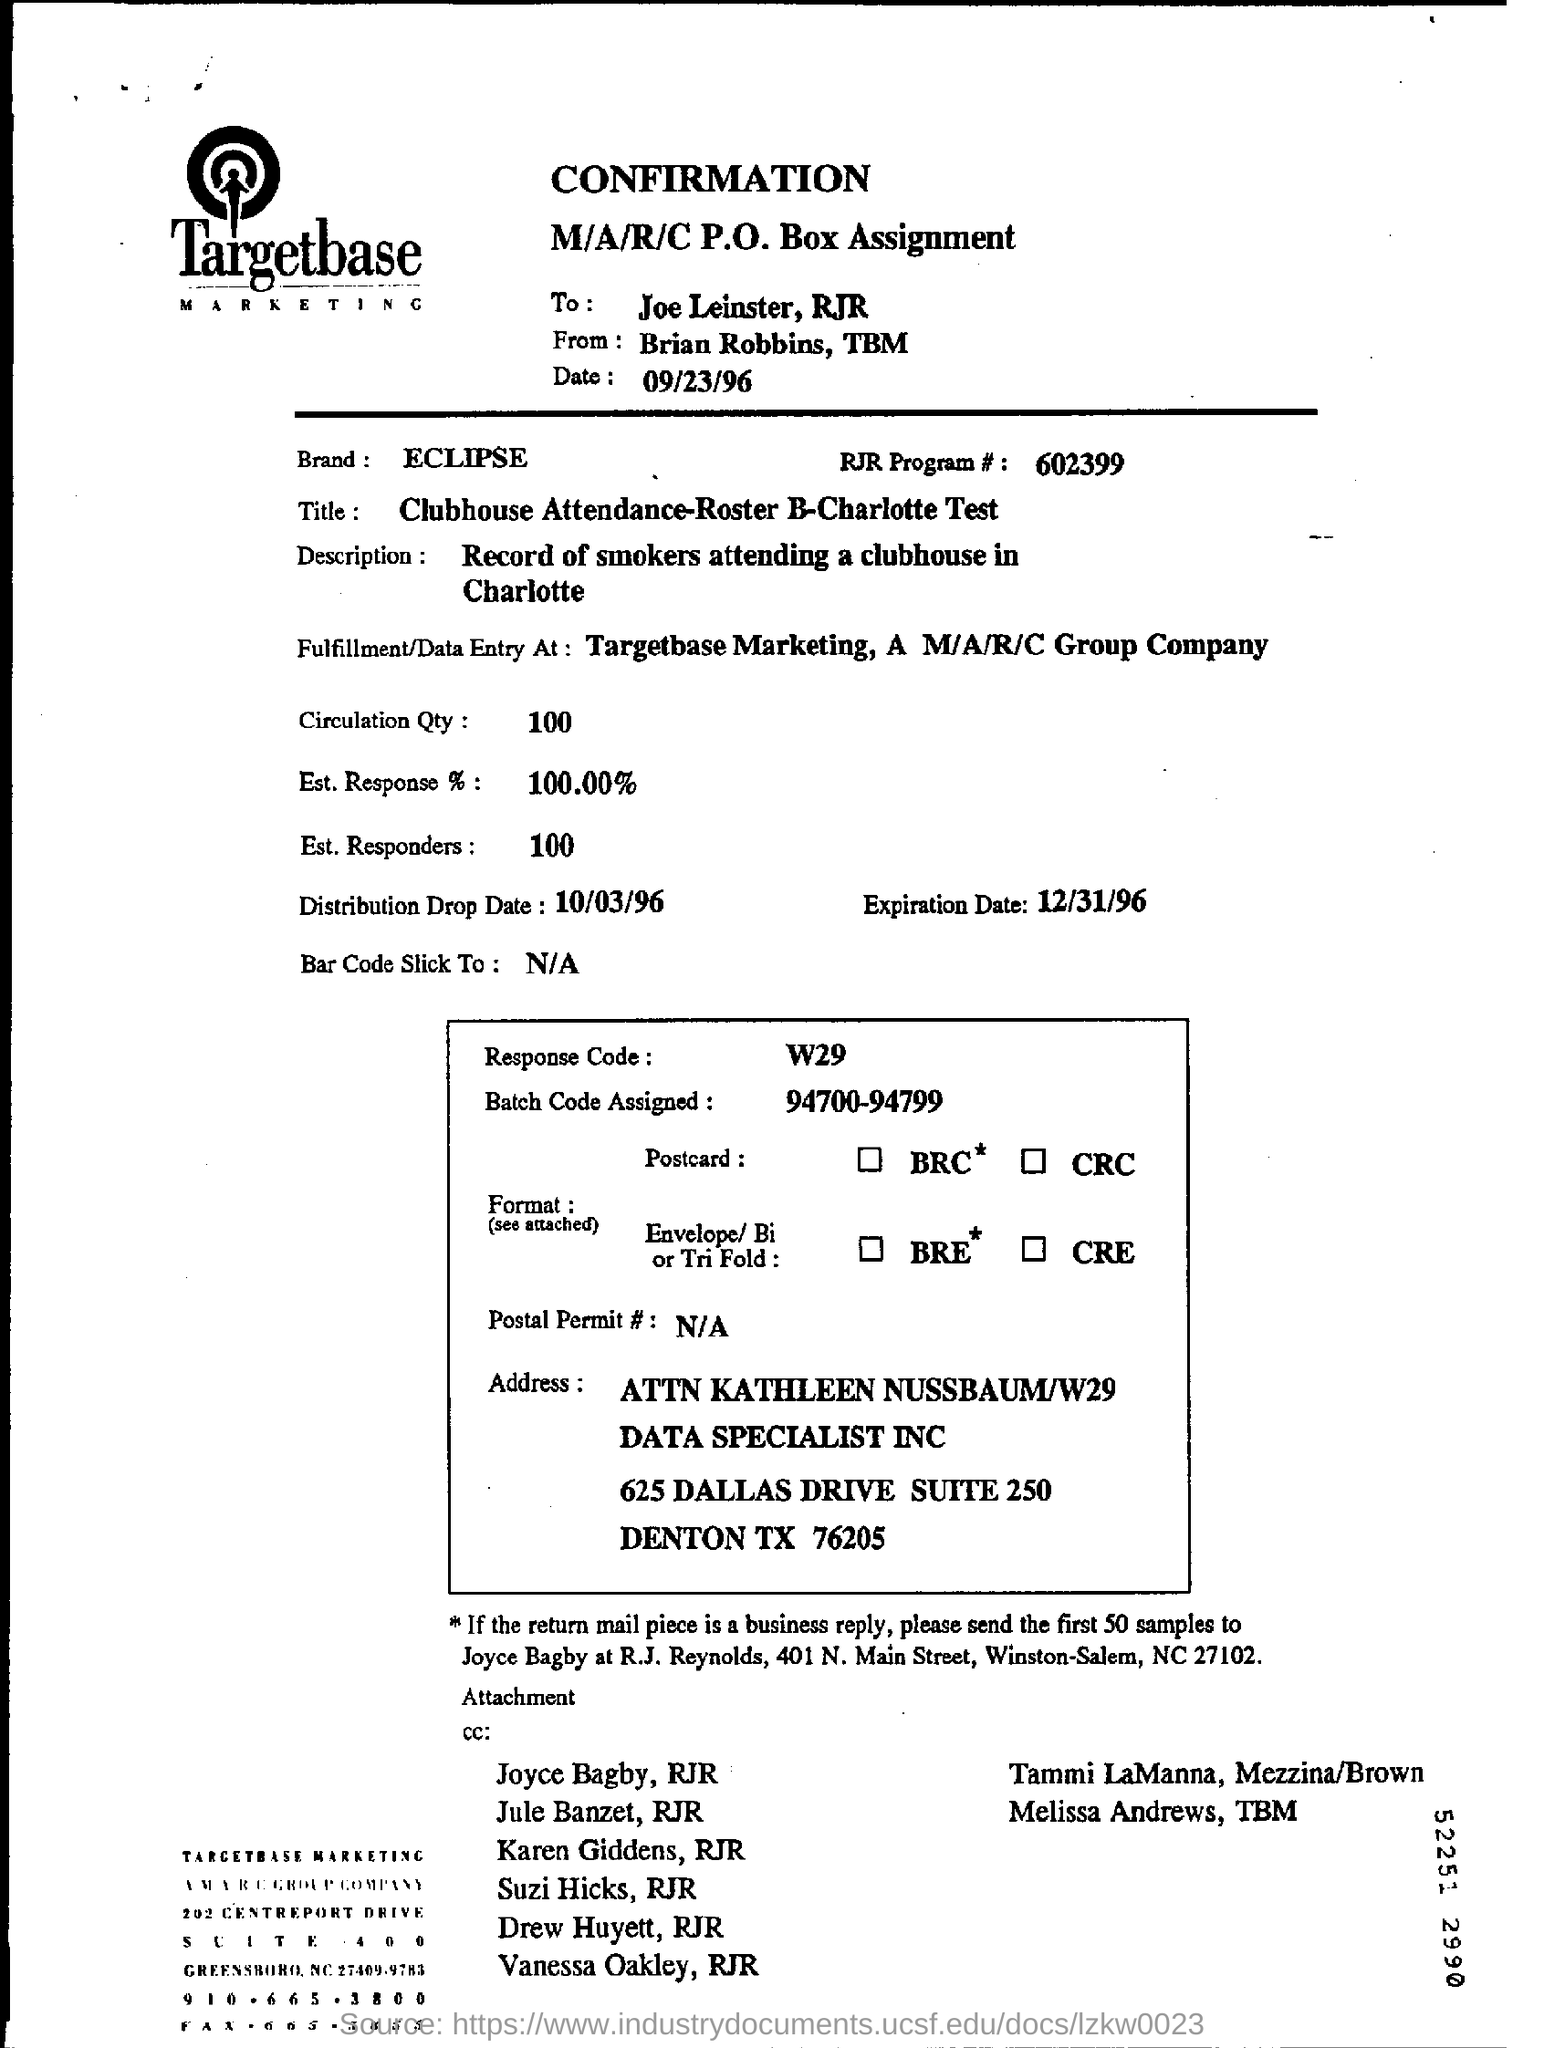What is the date of expiration date?
Your answer should be very brief. 12/31/96. What is the number of the rjr program# ?
Provide a succinct answer. 602399. How much rate for the est. response?
Your answer should be very brief. 100.00. What is the name of marketing ?
Provide a short and direct response. Targetbase Marketing. 